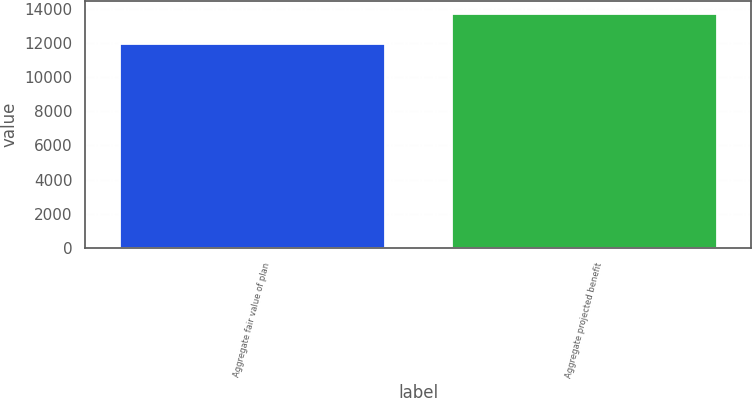Convert chart to OTSL. <chart><loc_0><loc_0><loc_500><loc_500><bar_chart><fcel>Aggregate fair value of plan<fcel>Aggregate projected benefit<nl><fcel>11979<fcel>13756<nl></chart> 